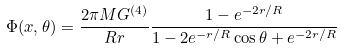Convert formula to latex. <formula><loc_0><loc_0><loc_500><loc_500>\Phi ( { x } , \theta ) = \frac { 2 \pi M G ^ { ( 4 ) } } { R r } \frac { 1 - e ^ { - 2 r / R } } { 1 - 2 e ^ { - r / R } \cos \theta + e ^ { - 2 r / R } }</formula> 